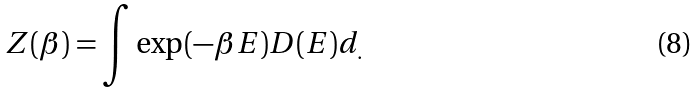<formula> <loc_0><loc_0><loc_500><loc_500>Z ( \beta ) = \int \exp ( - \beta E ) D ( E ) d _ { . }</formula> 